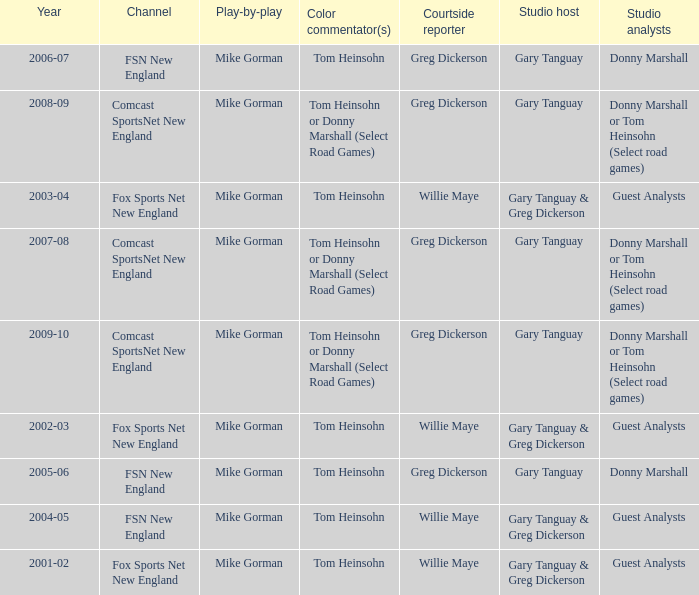Who is the studio host for the year 2006-07? Gary Tanguay. 